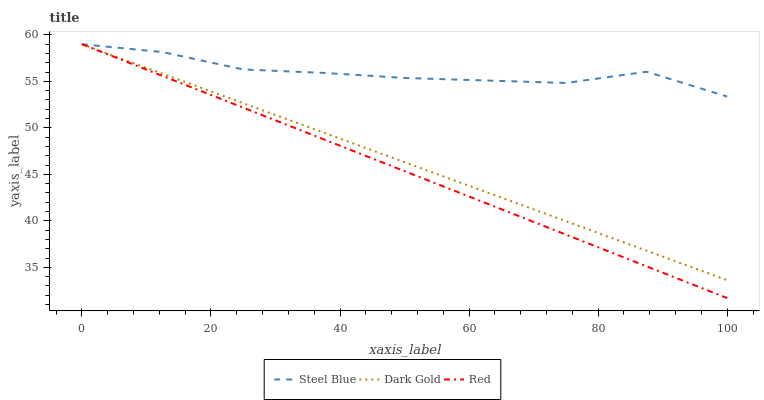Does Red have the minimum area under the curve?
Answer yes or no. Yes. Does Steel Blue have the maximum area under the curve?
Answer yes or no. Yes. Does Dark Gold have the minimum area under the curve?
Answer yes or no. No. Does Dark Gold have the maximum area under the curve?
Answer yes or no. No. Is Dark Gold the smoothest?
Answer yes or no. Yes. Is Steel Blue the roughest?
Answer yes or no. Yes. Is Red the smoothest?
Answer yes or no. No. Is Red the roughest?
Answer yes or no. No. Does Red have the lowest value?
Answer yes or no. Yes. Does Dark Gold have the lowest value?
Answer yes or no. No. Does Dark Gold have the highest value?
Answer yes or no. Yes. Does Red intersect Dark Gold?
Answer yes or no. Yes. Is Red less than Dark Gold?
Answer yes or no. No. Is Red greater than Dark Gold?
Answer yes or no. No. 